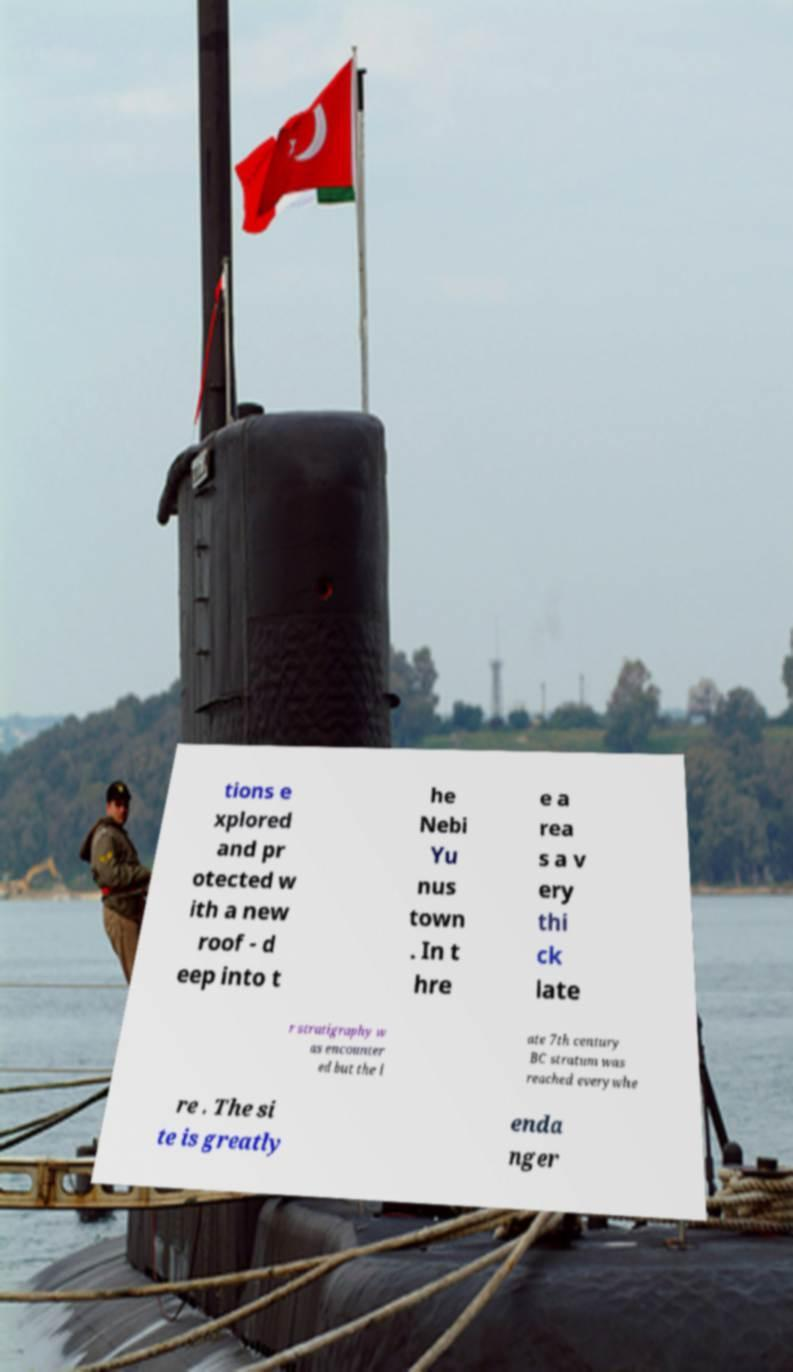Please identify and transcribe the text found in this image. tions e xplored and pr otected w ith a new roof - d eep into t he Nebi Yu nus town . In t hre e a rea s a v ery thi ck late r stratigraphy w as encounter ed but the l ate 7th century BC stratum was reached everywhe re . The si te is greatly enda nger 